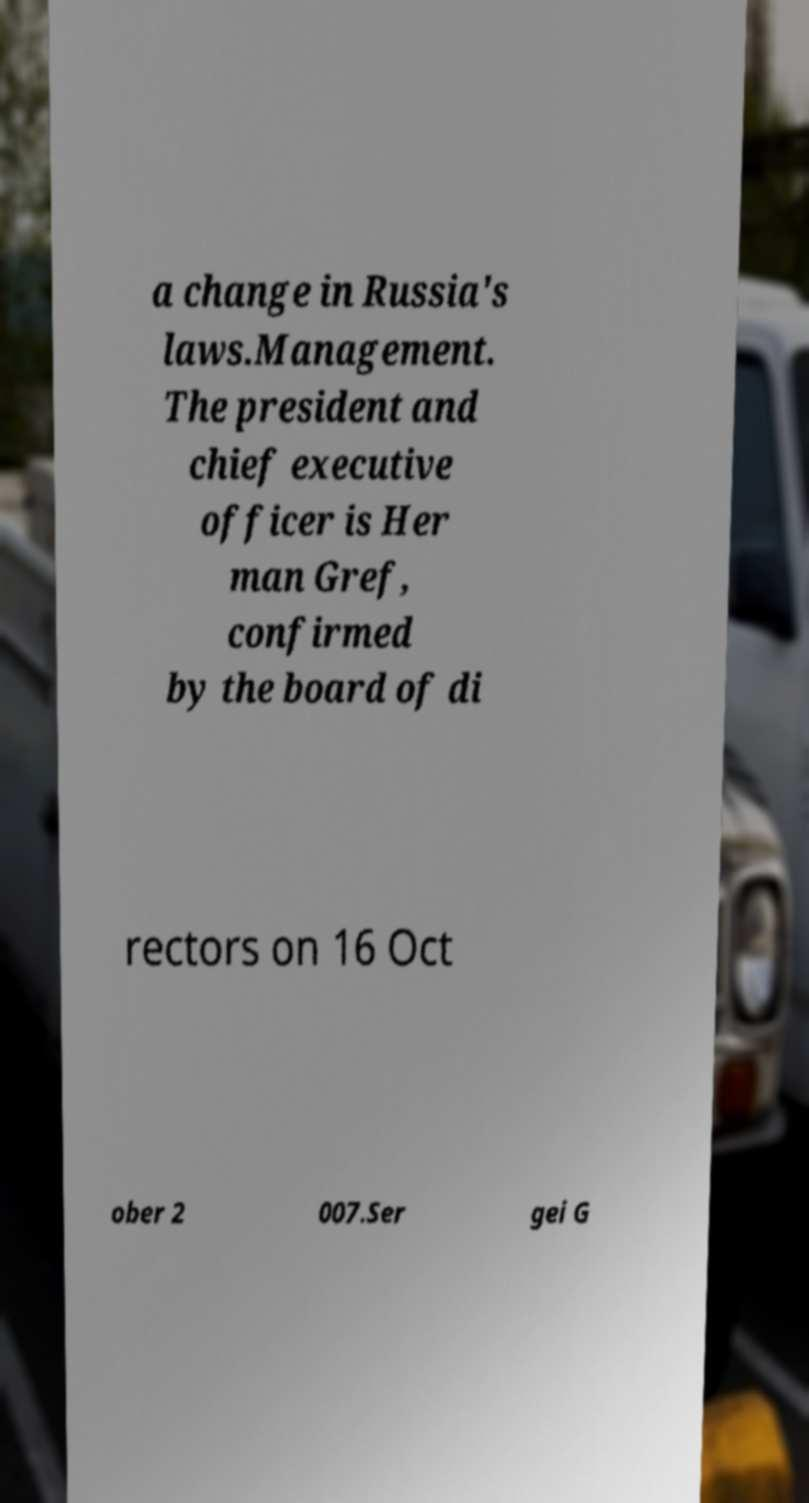Please read and relay the text visible in this image. What does it say? a change in Russia's laws.Management. The president and chief executive officer is Her man Gref, confirmed by the board of di rectors on 16 Oct ober 2 007.Ser gei G 